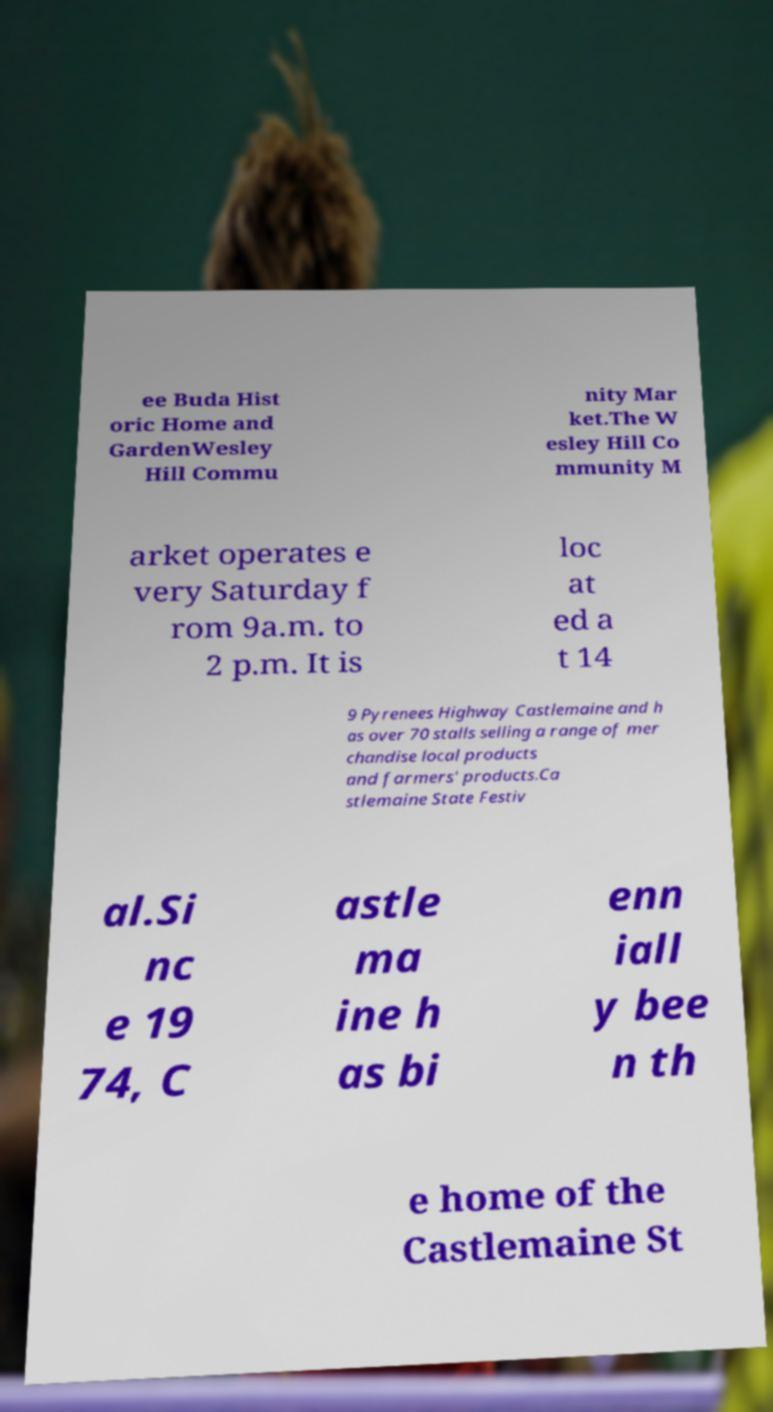For documentation purposes, I need the text within this image transcribed. Could you provide that? ee Buda Hist oric Home and GardenWesley Hill Commu nity Mar ket.The W esley Hill Co mmunity M arket operates e very Saturday f rom 9a.m. to 2 p.m. It is loc at ed a t 14 9 Pyrenees Highway Castlemaine and h as over 70 stalls selling a range of mer chandise local products and farmers' products.Ca stlemaine State Festiv al.Si nc e 19 74, C astle ma ine h as bi enn iall y bee n th e home of the Castlemaine St 